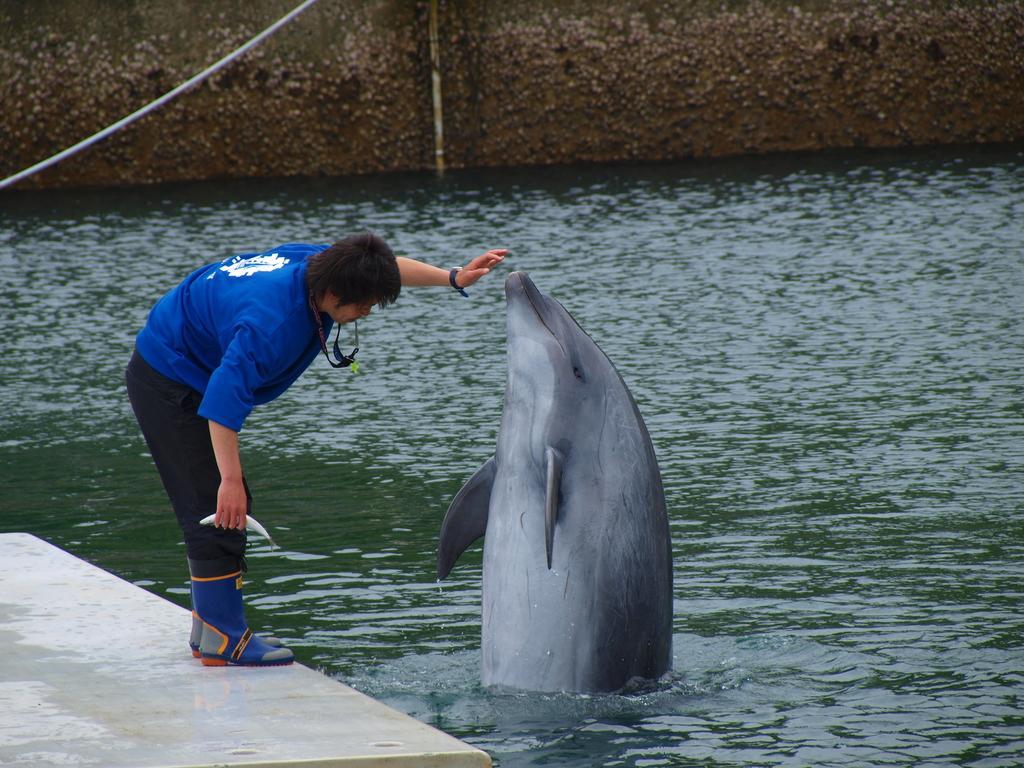How would you summarize this image in a sentence or two? In this image we can see a man is standing on the white color platform. He is wearing a blue T-shirt, pant, tag around his neck and holding fish in his hand. In front of the man, we can see a dolphin in the water. At the top of the image, we can see a wall and a wire. 